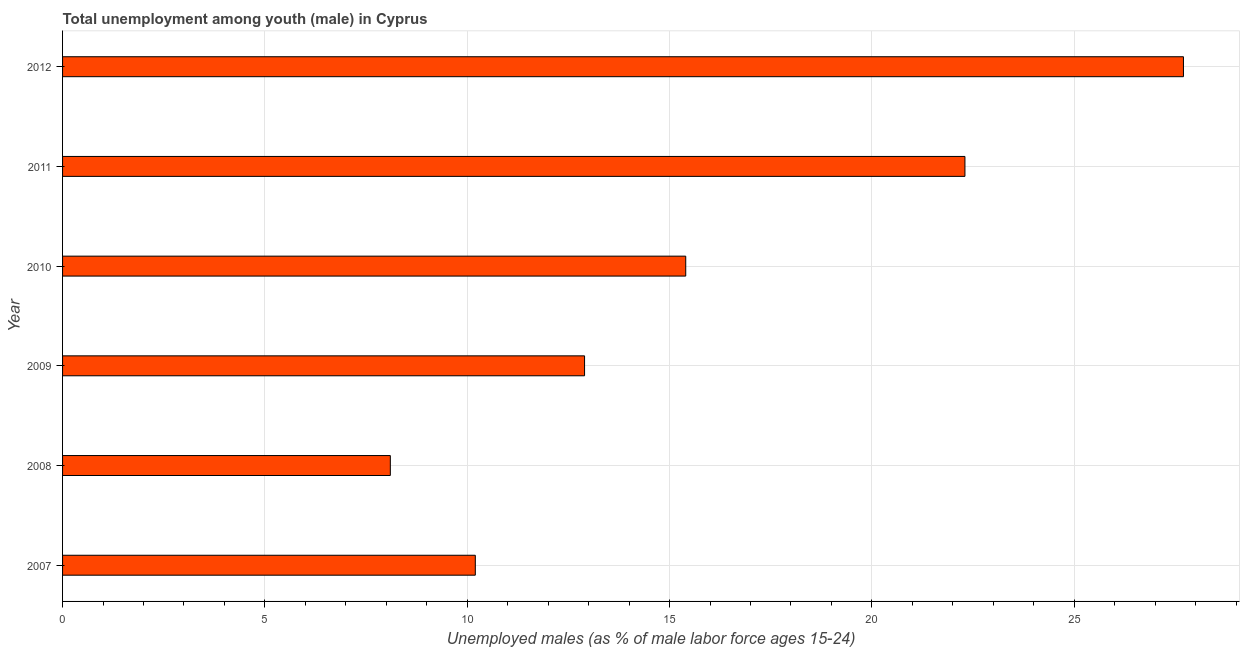Does the graph contain any zero values?
Offer a terse response. No. Does the graph contain grids?
Your response must be concise. Yes. What is the title of the graph?
Offer a very short reply. Total unemployment among youth (male) in Cyprus. What is the label or title of the X-axis?
Provide a short and direct response. Unemployed males (as % of male labor force ages 15-24). What is the label or title of the Y-axis?
Ensure brevity in your answer.  Year. What is the unemployed male youth population in 2010?
Keep it short and to the point. 15.4. Across all years, what is the maximum unemployed male youth population?
Offer a very short reply. 27.7. Across all years, what is the minimum unemployed male youth population?
Your answer should be compact. 8.1. In which year was the unemployed male youth population minimum?
Ensure brevity in your answer.  2008. What is the sum of the unemployed male youth population?
Keep it short and to the point. 96.6. What is the difference between the unemployed male youth population in 2007 and 2008?
Your response must be concise. 2.1. What is the average unemployed male youth population per year?
Make the answer very short. 16.1. What is the median unemployed male youth population?
Provide a short and direct response. 14.15. What is the ratio of the unemployed male youth population in 2010 to that in 2012?
Make the answer very short. 0.56. Is the sum of the unemployed male youth population in 2007 and 2010 greater than the maximum unemployed male youth population across all years?
Give a very brief answer. No. What is the difference between the highest and the lowest unemployed male youth population?
Make the answer very short. 19.6. In how many years, is the unemployed male youth population greater than the average unemployed male youth population taken over all years?
Give a very brief answer. 2. How many years are there in the graph?
Offer a terse response. 6. Are the values on the major ticks of X-axis written in scientific E-notation?
Your response must be concise. No. What is the Unemployed males (as % of male labor force ages 15-24) of 2007?
Your answer should be very brief. 10.2. What is the Unemployed males (as % of male labor force ages 15-24) of 2008?
Offer a terse response. 8.1. What is the Unemployed males (as % of male labor force ages 15-24) in 2009?
Make the answer very short. 12.9. What is the Unemployed males (as % of male labor force ages 15-24) in 2010?
Give a very brief answer. 15.4. What is the Unemployed males (as % of male labor force ages 15-24) of 2011?
Give a very brief answer. 22.3. What is the Unemployed males (as % of male labor force ages 15-24) of 2012?
Offer a terse response. 27.7. What is the difference between the Unemployed males (as % of male labor force ages 15-24) in 2007 and 2012?
Offer a very short reply. -17.5. What is the difference between the Unemployed males (as % of male labor force ages 15-24) in 2008 and 2011?
Give a very brief answer. -14.2. What is the difference between the Unemployed males (as % of male labor force ages 15-24) in 2008 and 2012?
Offer a very short reply. -19.6. What is the difference between the Unemployed males (as % of male labor force ages 15-24) in 2009 and 2011?
Your answer should be compact. -9.4. What is the difference between the Unemployed males (as % of male labor force ages 15-24) in 2009 and 2012?
Give a very brief answer. -14.8. What is the difference between the Unemployed males (as % of male labor force ages 15-24) in 2010 and 2011?
Provide a short and direct response. -6.9. What is the difference between the Unemployed males (as % of male labor force ages 15-24) in 2011 and 2012?
Make the answer very short. -5.4. What is the ratio of the Unemployed males (as % of male labor force ages 15-24) in 2007 to that in 2008?
Provide a succinct answer. 1.26. What is the ratio of the Unemployed males (as % of male labor force ages 15-24) in 2007 to that in 2009?
Offer a very short reply. 0.79. What is the ratio of the Unemployed males (as % of male labor force ages 15-24) in 2007 to that in 2010?
Your response must be concise. 0.66. What is the ratio of the Unemployed males (as % of male labor force ages 15-24) in 2007 to that in 2011?
Provide a short and direct response. 0.46. What is the ratio of the Unemployed males (as % of male labor force ages 15-24) in 2007 to that in 2012?
Provide a short and direct response. 0.37. What is the ratio of the Unemployed males (as % of male labor force ages 15-24) in 2008 to that in 2009?
Offer a very short reply. 0.63. What is the ratio of the Unemployed males (as % of male labor force ages 15-24) in 2008 to that in 2010?
Make the answer very short. 0.53. What is the ratio of the Unemployed males (as % of male labor force ages 15-24) in 2008 to that in 2011?
Ensure brevity in your answer.  0.36. What is the ratio of the Unemployed males (as % of male labor force ages 15-24) in 2008 to that in 2012?
Keep it short and to the point. 0.29. What is the ratio of the Unemployed males (as % of male labor force ages 15-24) in 2009 to that in 2010?
Ensure brevity in your answer.  0.84. What is the ratio of the Unemployed males (as % of male labor force ages 15-24) in 2009 to that in 2011?
Keep it short and to the point. 0.58. What is the ratio of the Unemployed males (as % of male labor force ages 15-24) in 2009 to that in 2012?
Offer a very short reply. 0.47. What is the ratio of the Unemployed males (as % of male labor force ages 15-24) in 2010 to that in 2011?
Provide a short and direct response. 0.69. What is the ratio of the Unemployed males (as % of male labor force ages 15-24) in 2010 to that in 2012?
Your answer should be compact. 0.56. What is the ratio of the Unemployed males (as % of male labor force ages 15-24) in 2011 to that in 2012?
Ensure brevity in your answer.  0.81. 